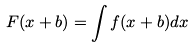Convert formula to latex. <formula><loc_0><loc_0><loc_500><loc_500>F ( x + b ) = \int f ( x + b ) d x</formula> 